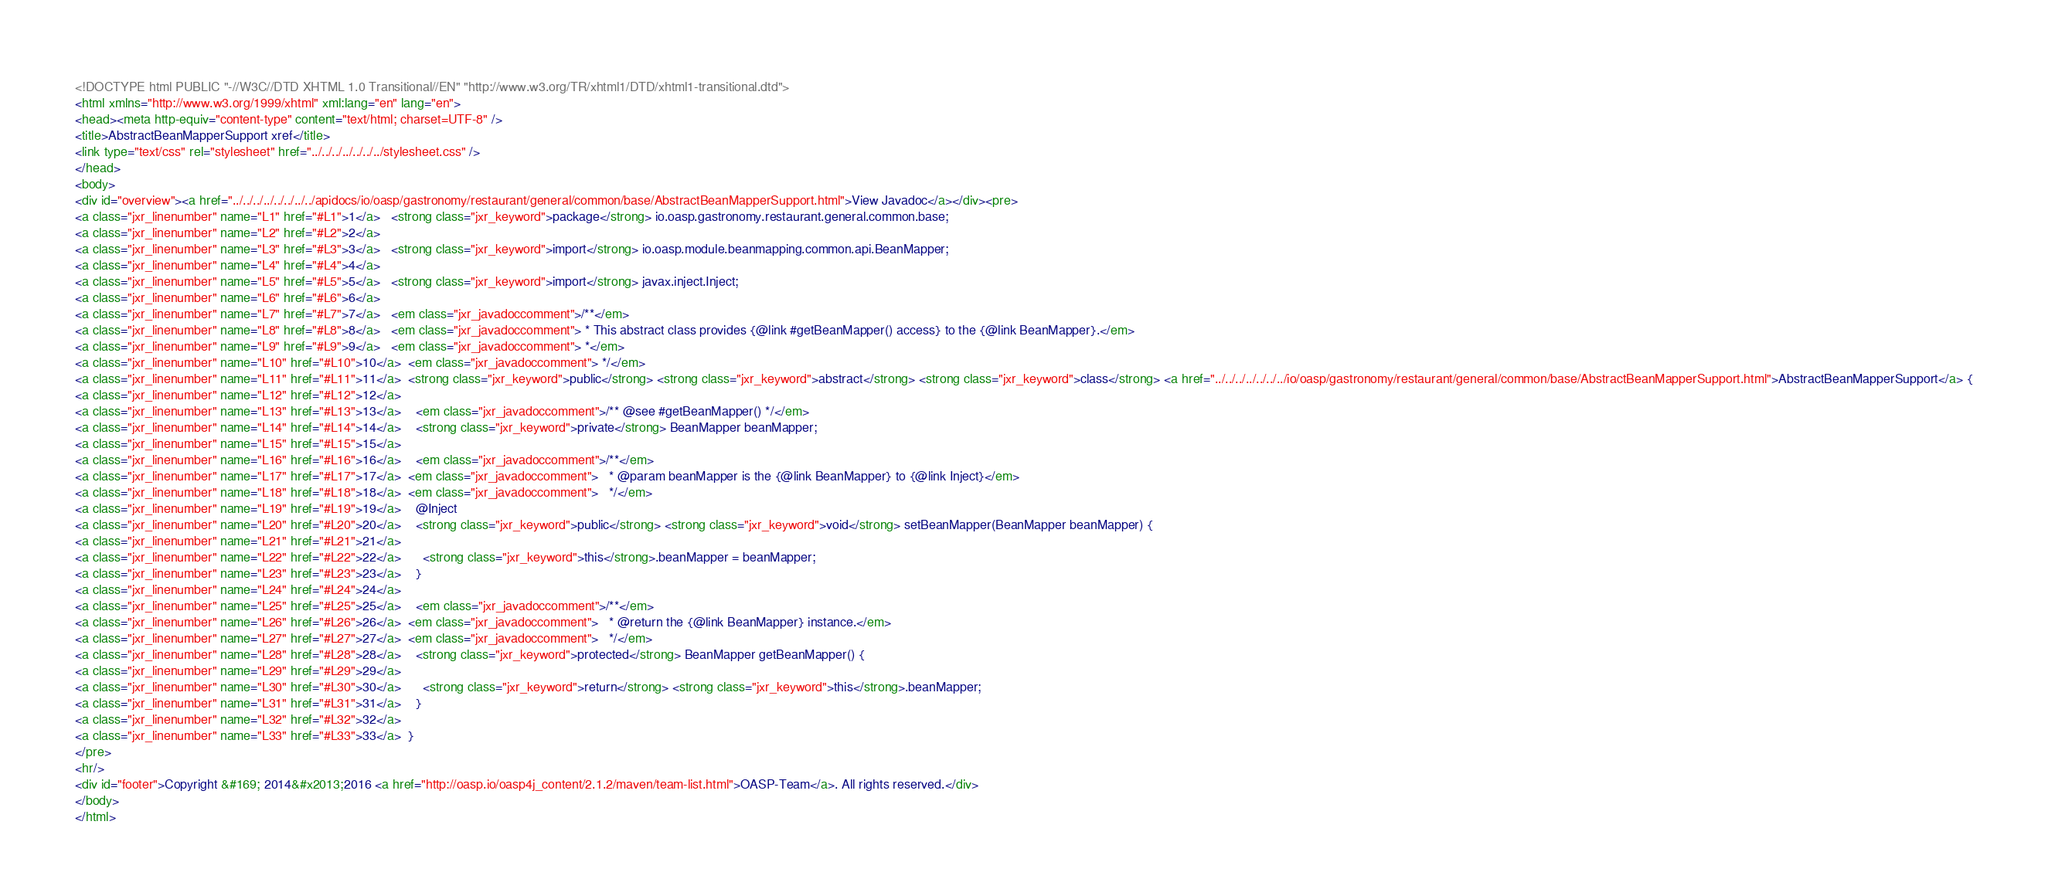Convert code to text. <code><loc_0><loc_0><loc_500><loc_500><_HTML_><!DOCTYPE html PUBLIC "-//W3C//DTD XHTML 1.0 Transitional//EN" "http://www.w3.org/TR/xhtml1/DTD/xhtml1-transitional.dtd">
<html xmlns="http://www.w3.org/1999/xhtml" xml:lang="en" lang="en">
<head><meta http-equiv="content-type" content="text/html; charset=UTF-8" />
<title>AbstractBeanMapperSupport xref</title>
<link type="text/css" rel="stylesheet" href="../../../../../../../stylesheet.css" />
</head>
<body>
<div id="overview"><a href="../../../../../../../../apidocs/io/oasp/gastronomy/restaurant/general/common/base/AbstractBeanMapperSupport.html">View Javadoc</a></div><pre>
<a class="jxr_linenumber" name="L1" href="#L1">1</a>   <strong class="jxr_keyword">package</strong> io.oasp.gastronomy.restaurant.general.common.base;
<a class="jxr_linenumber" name="L2" href="#L2">2</a>   
<a class="jxr_linenumber" name="L3" href="#L3">3</a>   <strong class="jxr_keyword">import</strong> io.oasp.module.beanmapping.common.api.BeanMapper;
<a class="jxr_linenumber" name="L4" href="#L4">4</a>   
<a class="jxr_linenumber" name="L5" href="#L5">5</a>   <strong class="jxr_keyword">import</strong> javax.inject.Inject;
<a class="jxr_linenumber" name="L6" href="#L6">6</a>   
<a class="jxr_linenumber" name="L7" href="#L7">7</a>   <em class="jxr_javadoccomment">/**</em>
<a class="jxr_linenumber" name="L8" href="#L8">8</a>   <em class="jxr_javadoccomment"> * This abstract class provides {@link #getBeanMapper() access} to the {@link BeanMapper}.</em>
<a class="jxr_linenumber" name="L9" href="#L9">9</a>   <em class="jxr_javadoccomment"> *</em>
<a class="jxr_linenumber" name="L10" href="#L10">10</a>  <em class="jxr_javadoccomment"> */</em>
<a class="jxr_linenumber" name="L11" href="#L11">11</a>  <strong class="jxr_keyword">public</strong> <strong class="jxr_keyword">abstract</strong> <strong class="jxr_keyword">class</strong> <a href="../../../../../../../io/oasp/gastronomy/restaurant/general/common/base/AbstractBeanMapperSupport.html">AbstractBeanMapperSupport</a> {
<a class="jxr_linenumber" name="L12" href="#L12">12</a>  
<a class="jxr_linenumber" name="L13" href="#L13">13</a>    <em class="jxr_javadoccomment">/** @see #getBeanMapper() */</em>
<a class="jxr_linenumber" name="L14" href="#L14">14</a>    <strong class="jxr_keyword">private</strong> BeanMapper beanMapper;
<a class="jxr_linenumber" name="L15" href="#L15">15</a>  
<a class="jxr_linenumber" name="L16" href="#L16">16</a>    <em class="jxr_javadoccomment">/**</em>
<a class="jxr_linenumber" name="L17" href="#L17">17</a>  <em class="jxr_javadoccomment">   * @param beanMapper is the {@link BeanMapper} to {@link Inject}</em>
<a class="jxr_linenumber" name="L18" href="#L18">18</a>  <em class="jxr_javadoccomment">   */</em>
<a class="jxr_linenumber" name="L19" href="#L19">19</a>    @Inject
<a class="jxr_linenumber" name="L20" href="#L20">20</a>    <strong class="jxr_keyword">public</strong> <strong class="jxr_keyword">void</strong> setBeanMapper(BeanMapper beanMapper) {
<a class="jxr_linenumber" name="L21" href="#L21">21</a>  
<a class="jxr_linenumber" name="L22" href="#L22">22</a>      <strong class="jxr_keyword">this</strong>.beanMapper = beanMapper;
<a class="jxr_linenumber" name="L23" href="#L23">23</a>    }
<a class="jxr_linenumber" name="L24" href="#L24">24</a>  
<a class="jxr_linenumber" name="L25" href="#L25">25</a>    <em class="jxr_javadoccomment">/**</em>
<a class="jxr_linenumber" name="L26" href="#L26">26</a>  <em class="jxr_javadoccomment">   * @return the {@link BeanMapper} instance.</em>
<a class="jxr_linenumber" name="L27" href="#L27">27</a>  <em class="jxr_javadoccomment">   */</em>
<a class="jxr_linenumber" name="L28" href="#L28">28</a>    <strong class="jxr_keyword">protected</strong> BeanMapper getBeanMapper() {
<a class="jxr_linenumber" name="L29" href="#L29">29</a>  
<a class="jxr_linenumber" name="L30" href="#L30">30</a>      <strong class="jxr_keyword">return</strong> <strong class="jxr_keyword">this</strong>.beanMapper;
<a class="jxr_linenumber" name="L31" href="#L31">31</a>    }
<a class="jxr_linenumber" name="L32" href="#L32">32</a>  
<a class="jxr_linenumber" name="L33" href="#L33">33</a>  }
</pre>
<hr/>
<div id="footer">Copyright &#169; 2014&#x2013;2016 <a href="http://oasp.io/oasp4j_content/2.1.2/maven/team-list.html">OASP-Team</a>. All rights reserved.</div>
</body>
</html>
</code> 